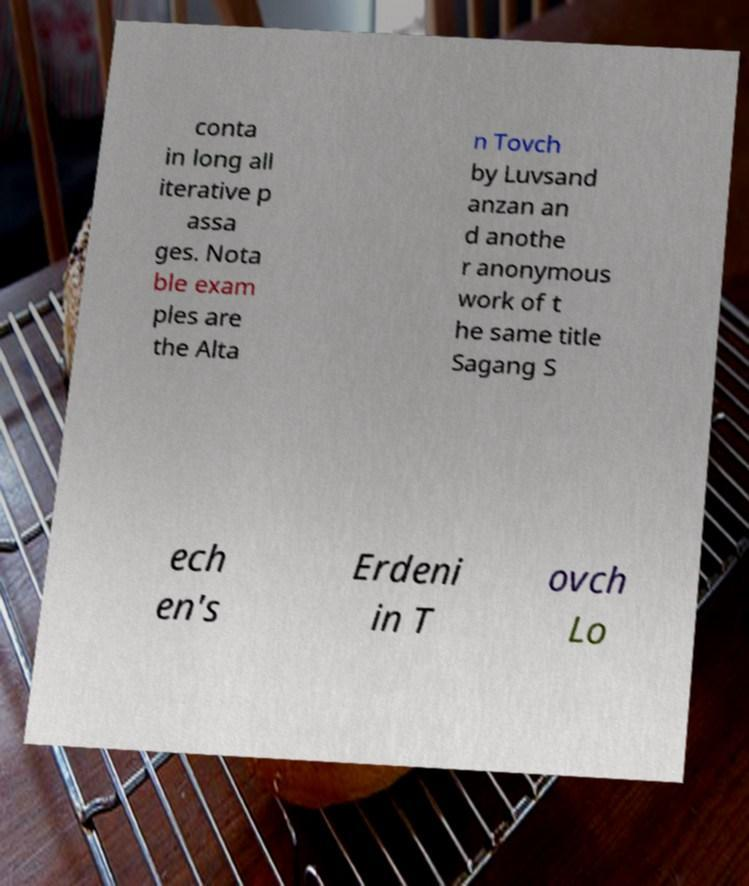Please read and relay the text visible in this image. What does it say? conta in long all iterative p assa ges. Nota ble exam ples are the Alta n Tovch by Luvsand anzan an d anothe r anonymous work of t he same title Sagang S ech en's Erdeni in T ovch Lo 